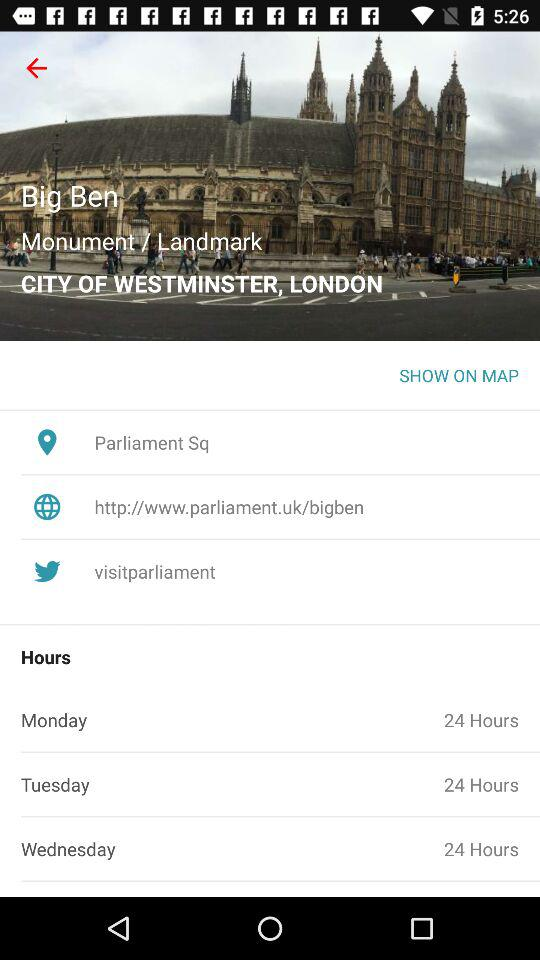What are the hours of monday? There are 24 hours on Monday. 